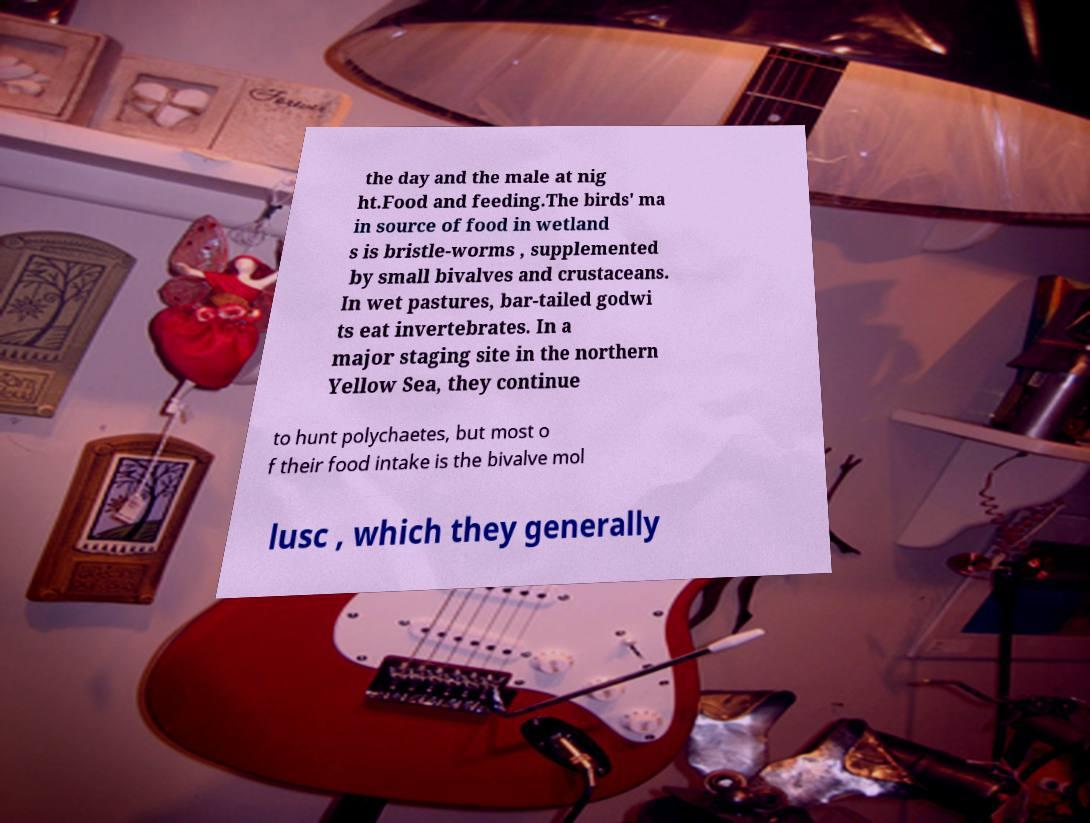Could you extract and type out the text from this image? the day and the male at nig ht.Food and feeding.The birds' ma in source of food in wetland s is bristle-worms , supplemented by small bivalves and crustaceans. In wet pastures, bar-tailed godwi ts eat invertebrates. In a major staging site in the northern Yellow Sea, they continue to hunt polychaetes, but most o f their food intake is the bivalve mol lusc , which they generally 